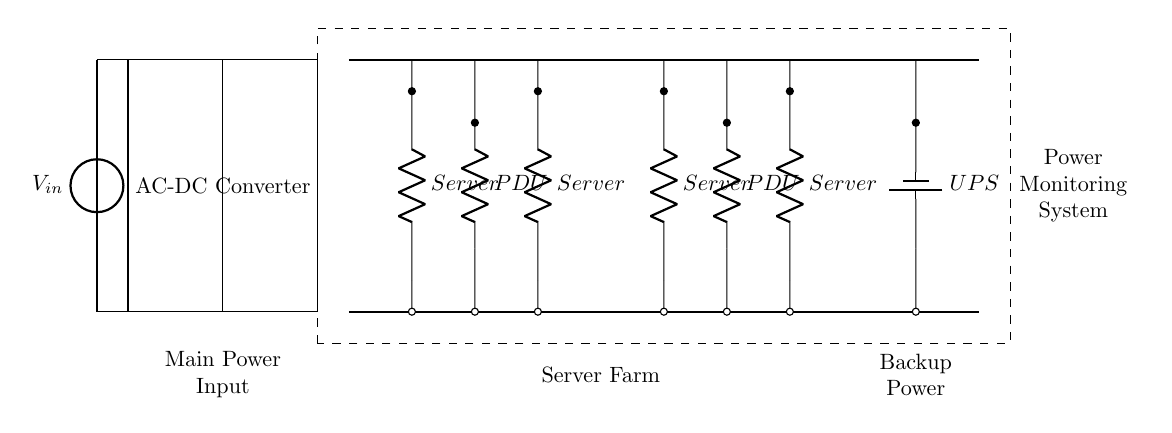What is the main power input of the circuit? The main power input is indicated by the voltage source labeled V_in, which supplies power to the circuit.
Answer: V_in How many Power Distribution Units are shown in the circuit? There are two Power Distribution Units (PDUs) illustrated, positioned at coordinates 6 and 10 on the diagram, labeled as PDU.
Answer: 2 What type of converter is used in the circuit? The circuit includes an AC-DC Converter as depicted in the large rectangle at coordinates 2,2, which converts alternating current to direct current.
Answer: AC-DC Converter What component provides backup power in this circuit? The backup power component is identified as the UPS, which is symbolized by a battery in the circuit and is connected at coordinates 13, representing where the backup power is sourced from.
Answer: UPS What is the function of the Power Monitoring System in the diagram? The Power Monitoring System, enclosed in a dashed rectangle at coordinates 3.5,-0.5 to 14.5,4.5, monitors the overall power usage and status of the circuit.
Answer: Monitoring Which components are directly connected to the DC Bus in the circuit? The DC Bus connects directly to the two PDUs and the UPS, which are located along the top line at coordinate 4 to 14, with the associated connections leading to these components.
Answer: PDUs and UPS 